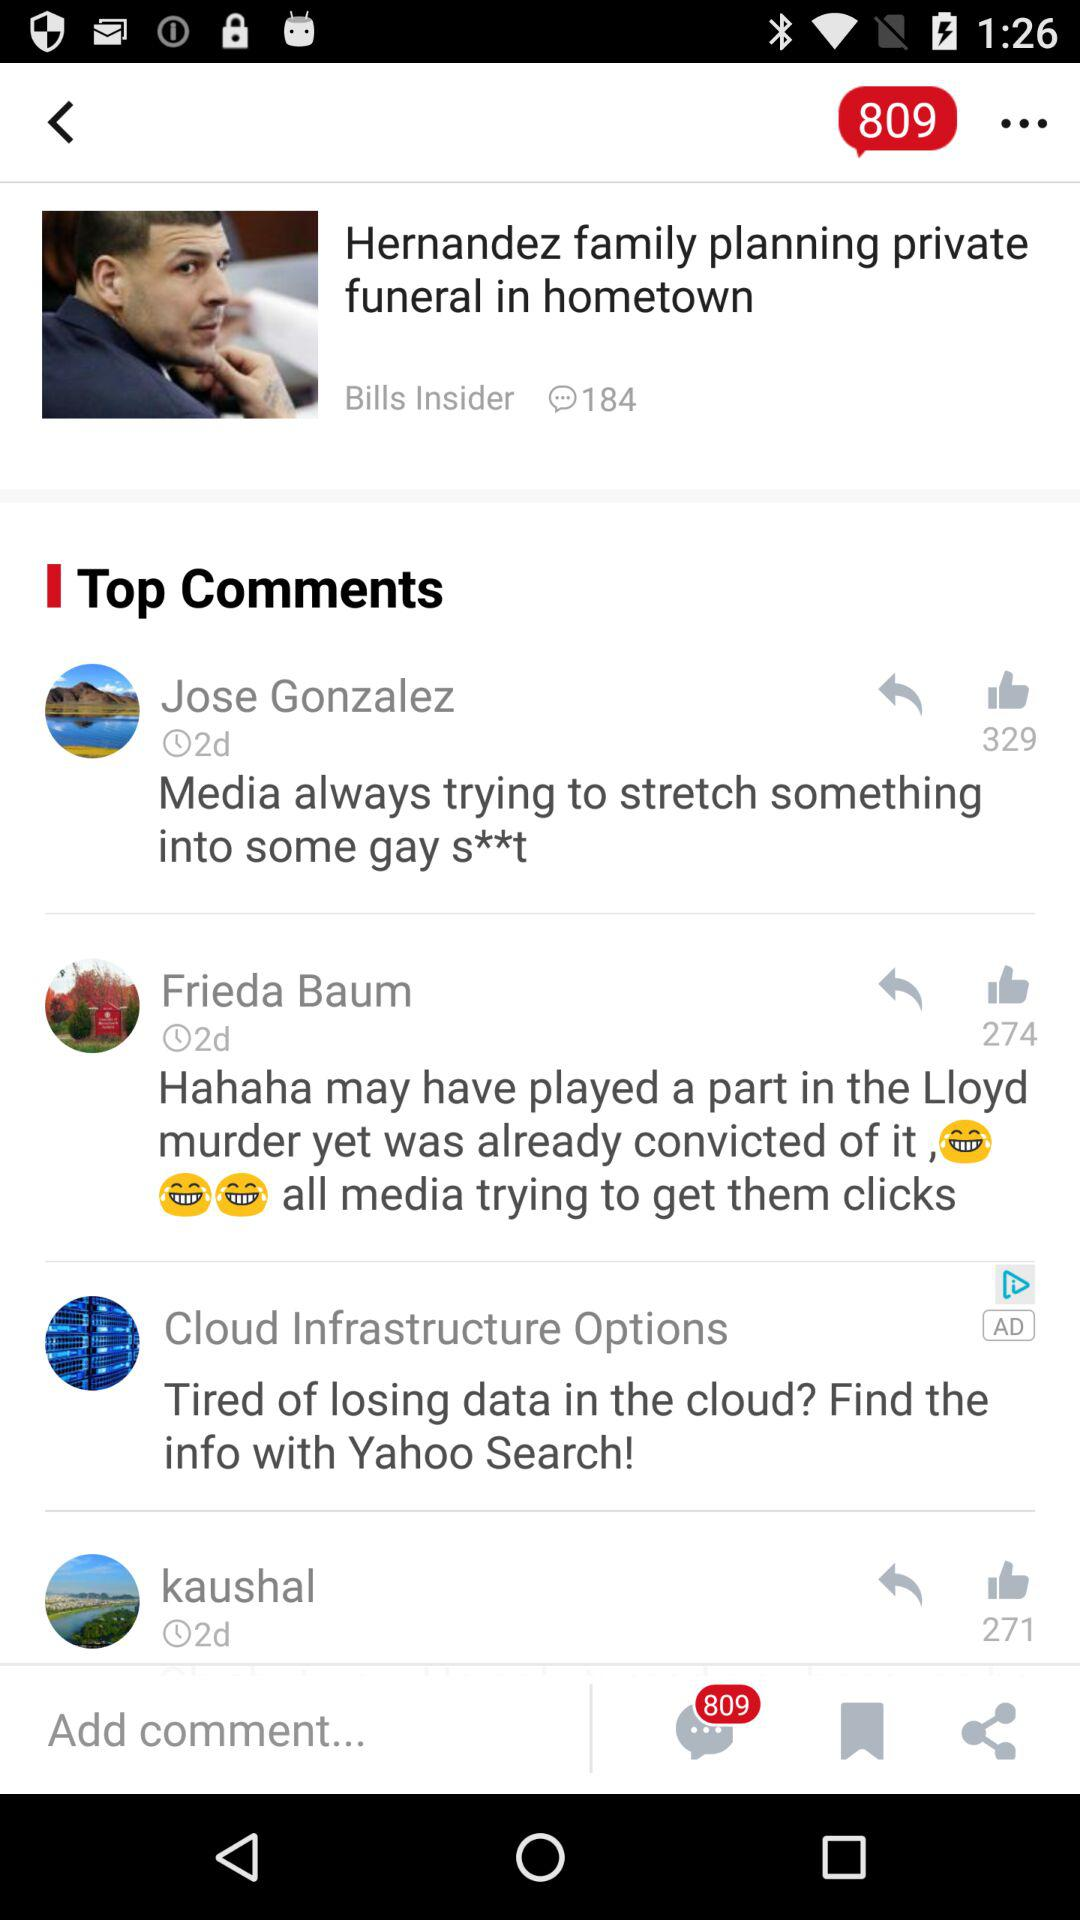How many comments are there in this article?
Answer the question using a single word or phrase. 3 